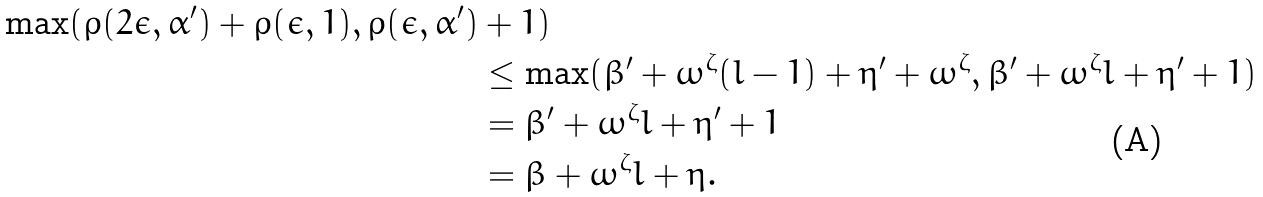Convert formula to latex. <formula><loc_0><loc_0><loc_500><loc_500>\max ( \rho ( 2 \epsilon , \alpha ^ { \prime } ) + \rho ( \epsilon , 1 ) , \rho ( \epsilon , \alpha ^ { \prime } ) & + 1 ) \\ & \leq \max ( \beta ^ { \prime } + \omega ^ { \zeta } ( l - 1 ) + \eta ^ { \prime } + \omega ^ { \zeta } , \beta ^ { \prime } + \omega ^ { \zeta } l + \eta ^ { \prime } + 1 ) \\ & = \beta ^ { \prime } + \omega ^ { \zeta } l + \eta ^ { \prime } + 1 \\ & = \beta + \omega ^ { \zeta } l + \eta .</formula> 